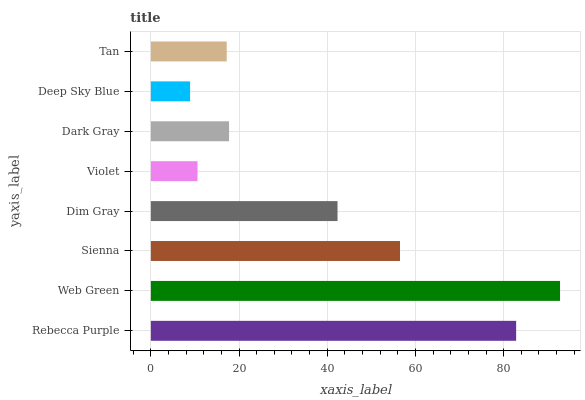Is Deep Sky Blue the minimum?
Answer yes or no. Yes. Is Web Green the maximum?
Answer yes or no. Yes. Is Sienna the minimum?
Answer yes or no. No. Is Sienna the maximum?
Answer yes or no. No. Is Web Green greater than Sienna?
Answer yes or no. Yes. Is Sienna less than Web Green?
Answer yes or no. Yes. Is Sienna greater than Web Green?
Answer yes or no. No. Is Web Green less than Sienna?
Answer yes or no. No. Is Dim Gray the high median?
Answer yes or no. Yes. Is Dark Gray the low median?
Answer yes or no. Yes. Is Dark Gray the high median?
Answer yes or no. No. Is Violet the low median?
Answer yes or no. No. 